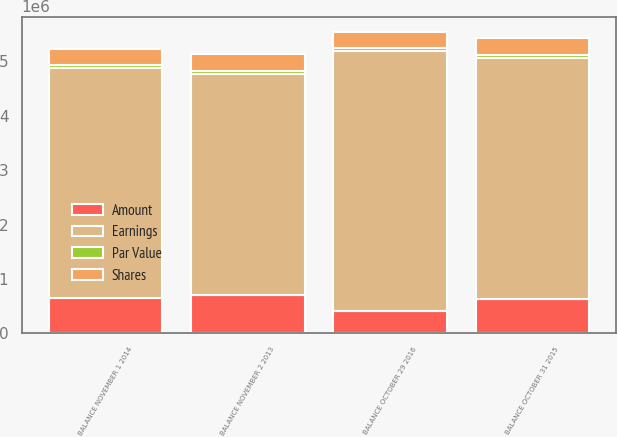Convert chart to OTSL. <chart><loc_0><loc_0><loc_500><loc_500><stacked_bar_chart><ecel><fcel>BALANCE NOVEMBER 2 2013<fcel>BALANCE NOVEMBER 1 2014<fcel>BALANCE OCTOBER 31 2015<fcel>BALANCE OCTOBER 29 2016<nl><fcel>Shares<fcel>311045<fcel>311205<fcel>312061<fcel>308171<nl><fcel>Par Value<fcel>51842<fcel>51869<fcel>52011<fcel>51363<nl><fcel>Amount<fcel>711879<fcel>643058<fcel>634484<fcel>402270<nl><fcel>Earnings<fcel>4.0564e+06<fcel>4.2315e+06<fcel>4.43732e+06<fcel>4.7858e+06<nl></chart> 